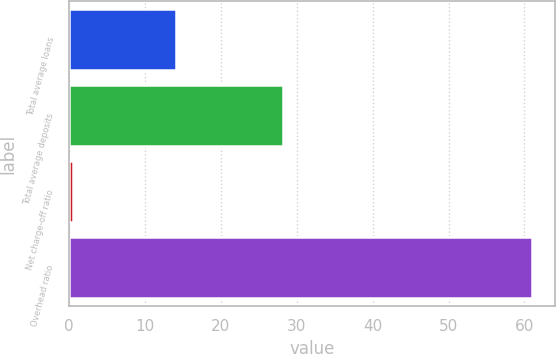Convert chart. <chart><loc_0><loc_0><loc_500><loc_500><bar_chart><fcel>Total average loans<fcel>Total average deposits<fcel>Net charge-off ratio<fcel>Overhead ratio<nl><fcel>14.1<fcel>28.2<fcel>0.49<fcel>61<nl></chart> 